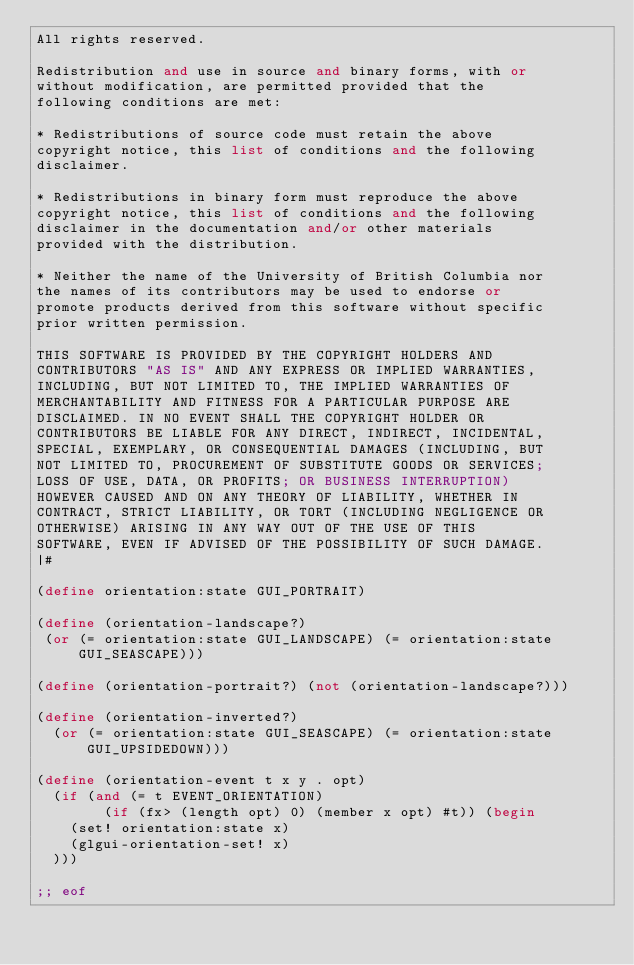Convert code to text. <code><loc_0><loc_0><loc_500><loc_500><_Scheme_>All rights reserved.

Redistribution and use in source and binary forms, with or
without modification, are permitted provided that the
following conditions are met:

* Redistributions of source code must retain the above
copyright notice, this list of conditions and the following
disclaimer.

* Redistributions in binary form must reproduce the above
copyright notice, this list of conditions and the following
disclaimer in the documentation and/or other materials
provided with the distribution.

* Neither the name of the University of British Columbia nor
the names of its contributors may be used to endorse or
promote products derived from this software without specific
prior written permission.

THIS SOFTWARE IS PROVIDED BY THE COPYRIGHT HOLDERS AND
CONTRIBUTORS "AS IS" AND ANY EXPRESS OR IMPLIED WARRANTIES,
INCLUDING, BUT NOT LIMITED TO, THE IMPLIED WARRANTIES OF
MERCHANTABILITY AND FITNESS FOR A PARTICULAR PURPOSE ARE
DISCLAIMED. IN NO EVENT SHALL THE COPYRIGHT HOLDER OR
CONTRIBUTORS BE LIABLE FOR ANY DIRECT, INDIRECT, INCIDENTAL,
SPECIAL, EXEMPLARY, OR CONSEQUENTIAL DAMAGES (INCLUDING, BUT
NOT LIMITED TO, PROCUREMENT OF SUBSTITUTE GOODS OR SERVICES;
LOSS OF USE, DATA, OR PROFITS; OR BUSINESS INTERRUPTION)
HOWEVER CAUSED AND ON ANY THEORY OF LIABILITY, WHETHER IN
CONTRACT, STRICT LIABILITY, OR TORT (INCLUDING NEGLIGENCE OR
OTHERWISE) ARISING IN ANY WAY OUT OF THE USE OF THIS
SOFTWARE, EVEN IF ADVISED OF THE POSSIBILITY OF SUCH DAMAGE.
|#

(define orientation:state GUI_PORTRAIT)

(define (orientation-landscape?)
 (or (= orientation:state GUI_LANDSCAPE) (= orientation:state GUI_SEASCAPE)))

(define (orientation-portrait?) (not (orientation-landscape?)))

(define (orientation-inverted?)
  (or (= orientation:state GUI_SEASCAPE) (= orientation:state GUI_UPSIDEDOWN)))

(define (orientation-event t x y . opt)
  (if (and (= t EVENT_ORIENTATION) 
        (if (fx> (length opt) 0) (member x opt) #t)) (begin
    (set! orientation:state x)
    (glgui-orientation-set! x)
  )))

;; eof
</code> 